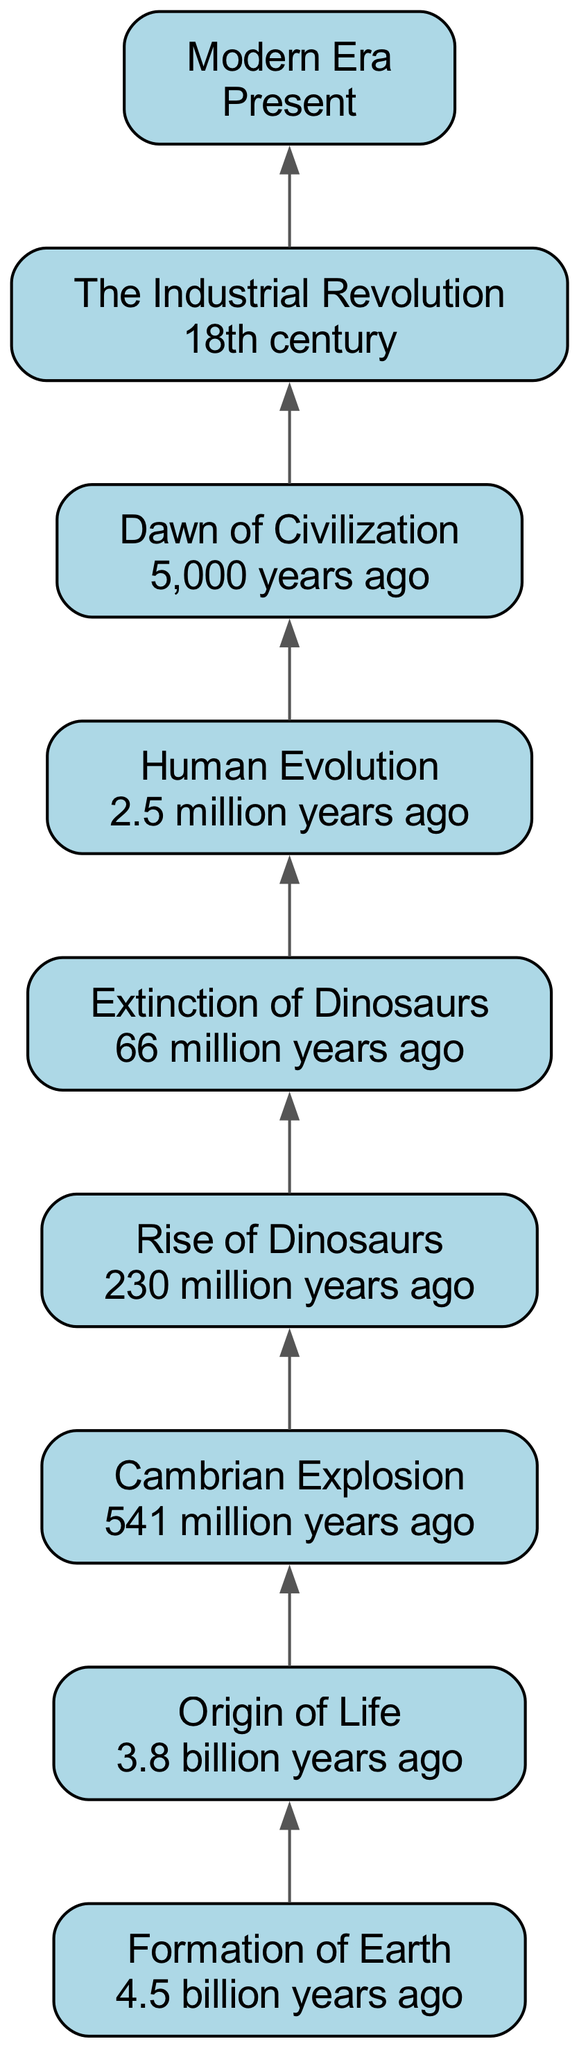What is the first event in the timeline? The timeline begins with the "Formation of Earth," which is the earliest event present before any other occurrences. Therefore, the first event is identified as such.
Answer: Formation of Earth How many total events are depicted in the diagram? A count of the nodes in the diagram shows there are eight distinct events mentioned, each to be learned sequentially from bottom to top.
Answer: Eight What is the time period for the "Dawn of Civilization"? This event specifies the emergence of first human civilizations occurring around 5,000 years ago, illustrating a significant development in human history.
Answer: 5,000 years ago Which event occurs directly after the "Extinction of Dinosaurs"? The diagram indicates a flow from the "Extinction of Dinosaurs" upwards to "Human Evolution," signifying that human evolution followed this mass extinction event.
Answer: Human Evolution What major event follows the "Industrial Revolution"? In the flowchart, it is clear that the "Modern Era" follows the "Industrial Revolution," indicating progress from industrial advances to contemporary advancements.
Answer: Modern Era What event is required for "Cambrian Explosion" to occur? The upward flow of the diagram shows that the "Origin of Life" is a prerequisite, as no diverse life can explode without its initial formation, making it a dependency.
Answer: Origin of Life Which two events are directly dependent on "Rise of Dinosaurs"? The diagram indicates the "Extinction of Dinosaurs" as an event dependent on the "Rise of Dinosaurs," plus "Human Evolution" further relies on the extinction state, showcasing a sequential dependency.
Answer: Extinction of Dinosaurs, Human Evolution What is the last event in the timeline? The diagram concludes with the "Modern Era," which signifies the present time, making it the ultimate event that encapsulates recent advancements and achievements in the timeline.
Answer: Modern Era 